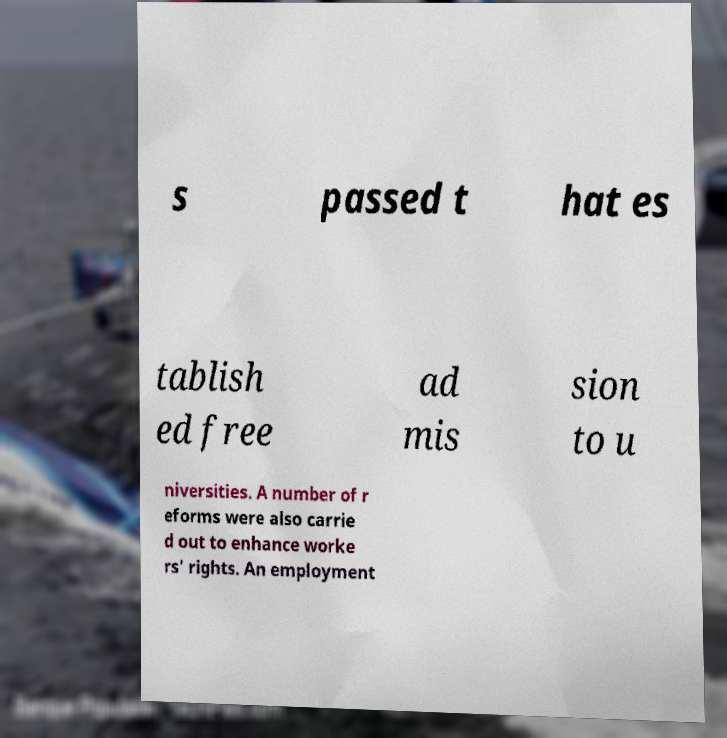Please read and relay the text visible in this image. What does it say? s passed t hat es tablish ed free ad mis sion to u niversities. A number of r eforms were also carrie d out to enhance worke rs' rights. An employment 